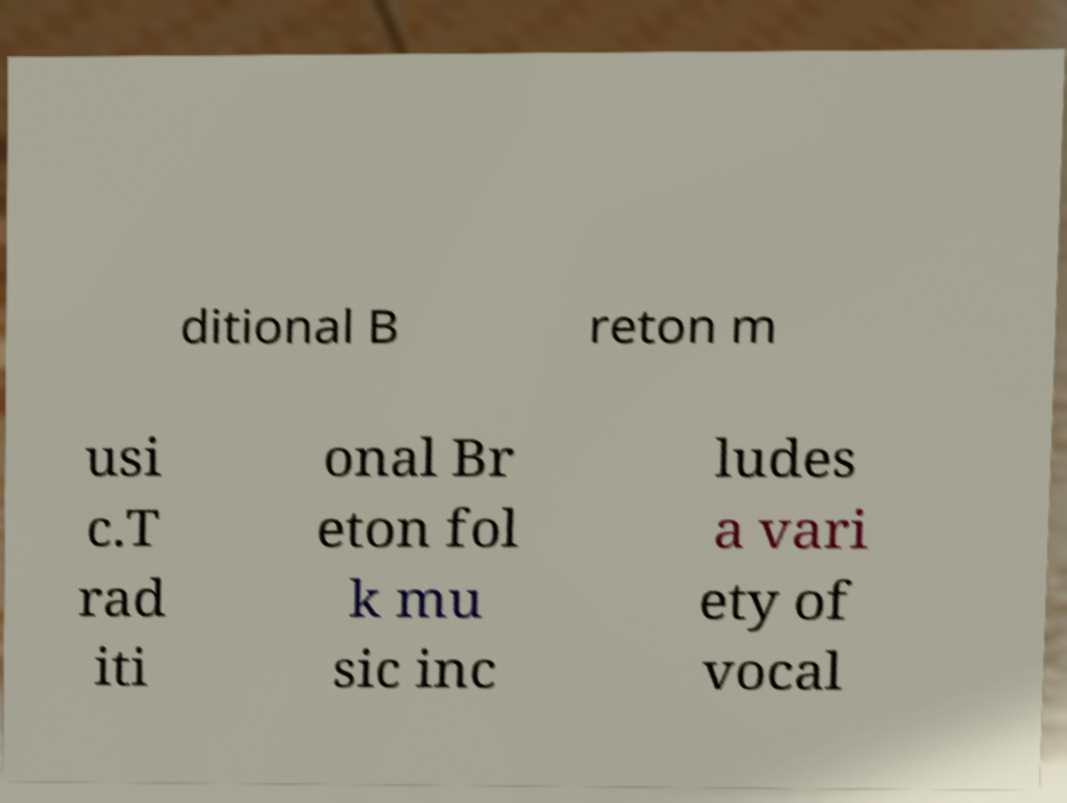Could you extract and type out the text from this image? ditional B reton m usi c.T rad iti onal Br eton fol k mu sic inc ludes a vari ety of vocal 